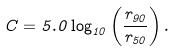Convert formula to latex. <formula><loc_0><loc_0><loc_500><loc_500>C = 5 . 0 \log _ { 1 0 } \left ( \frac { r _ { 9 0 } } { r _ { 5 0 } } \right ) .</formula> 